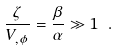<formula> <loc_0><loc_0><loc_500><loc_500>\frac { \zeta } { V _ { , \phi } } = \frac { \beta } { \alpha } \gg 1 \ .</formula> 